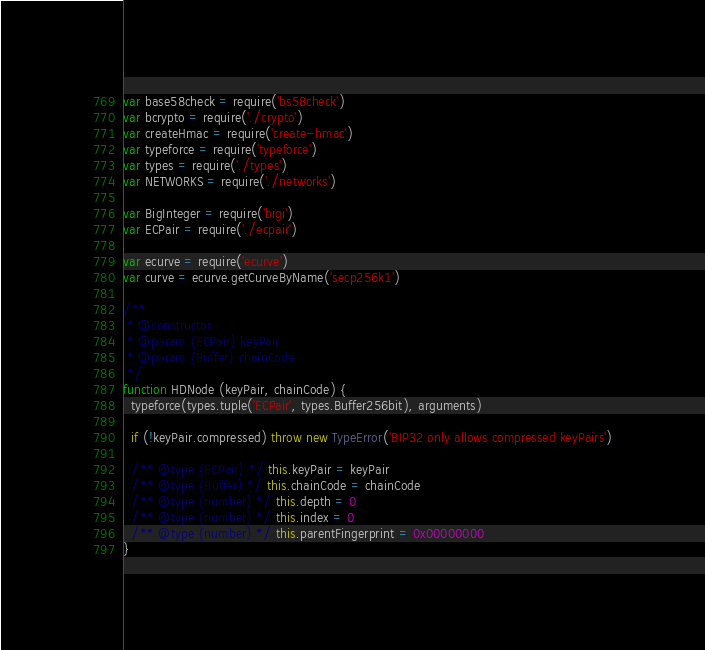<code> <loc_0><loc_0><loc_500><loc_500><_JavaScript_>var base58check = require('bs58check')
var bcrypto = require('./crypto')
var createHmac = require('create-hmac')
var typeforce = require('typeforce')
var types = require('./types')
var NETWORKS = require('./networks')

var BigInteger = require('bigi')
var ECPair = require('./ecpair')

var ecurve = require('ecurve')
var curve = ecurve.getCurveByName('secp256k1')

/**
 * @constructor
 * @param {ECPair} keyPair
 * @param {Buffer} chainCode
 */
function HDNode (keyPair, chainCode) {
  typeforce(types.tuple('ECPair', types.Buffer256bit), arguments)

  if (!keyPair.compressed) throw new TypeError('BIP32 only allows compressed keyPairs')

  /** @type {ECPair} */ this.keyPair = keyPair
  /** @type {Buffer} */ this.chainCode = chainCode
  /** @type {number} */ this.depth = 0
  /** @type {number} */ this.index = 0
  /** @type {number} */ this.parentFingerprint = 0x00000000
}
</code> 